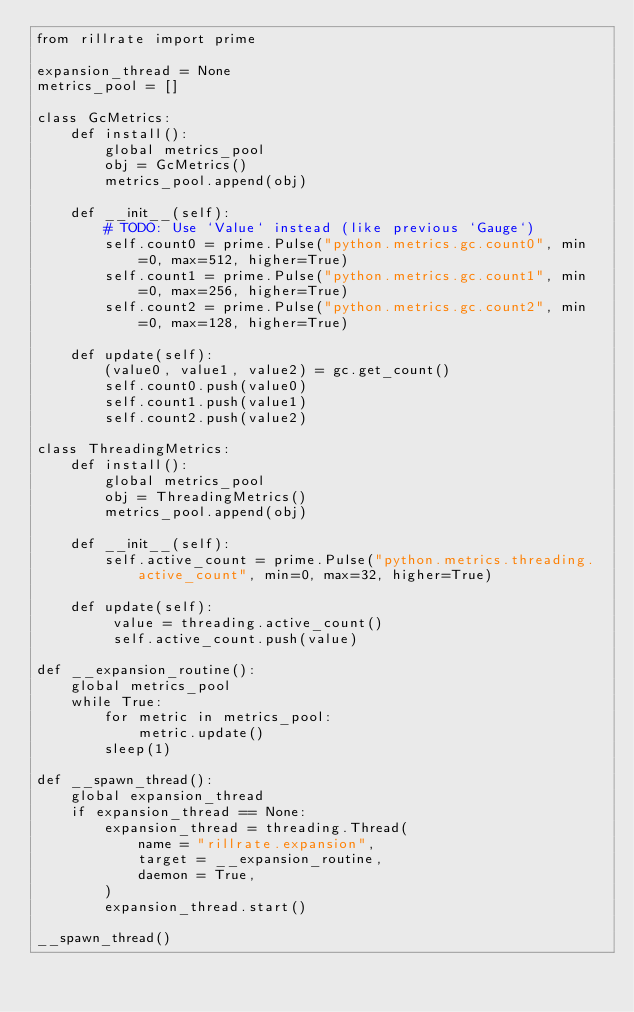Convert code to text. <code><loc_0><loc_0><loc_500><loc_500><_Python_>from rillrate import prime

expansion_thread = None
metrics_pool = []

class GcMetrics:
    def install():
        global metrics_pool
        obj = GcMetrics()
        metrics_pool.append(obj)

    def __init__(self):
        # TODO: Use `Value` instead (like previous `Gauge`)
        self.count0 = prime.Pulse("python.metrics.gc.count0", min=0, max=512, higher=True)
        self.count1 = prime.Pulse("python.metrics.gc.count1", min=0, max=256, higher=True)
        self.count2 = prime.Pulse("python.metrics.gc.count2", min=0, max=128, higher=True)

    def update(self):
        (value0, value1, value2) = gc.get_count()
        self.count0.push(value0)
        self.count1.push(value1)
        self.count2.push(value2)

class ThreadingMetrics:
    def install():
        global metrics_pool
        obj = ThreadingMetrics()
        metrics_pool.append(obj)

    def __init__(self):
        self.active_count = prime.Pulse("python.metrics.threading.active_count", min=0, max=32, higher=True)

    def update(self):
         value = threading.active_count()
         self.active_count.push(value)

def __expansion_routine():
    global metrics_pool
    while True:
        for metric in metrics_pool:
            metric.update()
        sleep(1)

def __spawn_thread():
    global expansion_thread
    if expansion_thread == None:
        expansion_thread = threading.Thread(
            name = "rillrate.expansion",
            target = __expansion_routine,
            daemon = True,
        )
        expansion_thread.start()

__spawn_thread()
</code> 